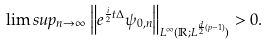<formula> <loc_0><loc_0><loc_500><loc_500>\lim s u p _ { n \to \infty } \left \| e ^ { \frac { i } { 2 } t \Delta } \psi _ { 0 , n } \right \| _ { L ^ { \infty } ( \mathbb { R } ; L ^ { \frac { d } { 2 } ( p - 1 ) } ) } > 0 .</formula> 